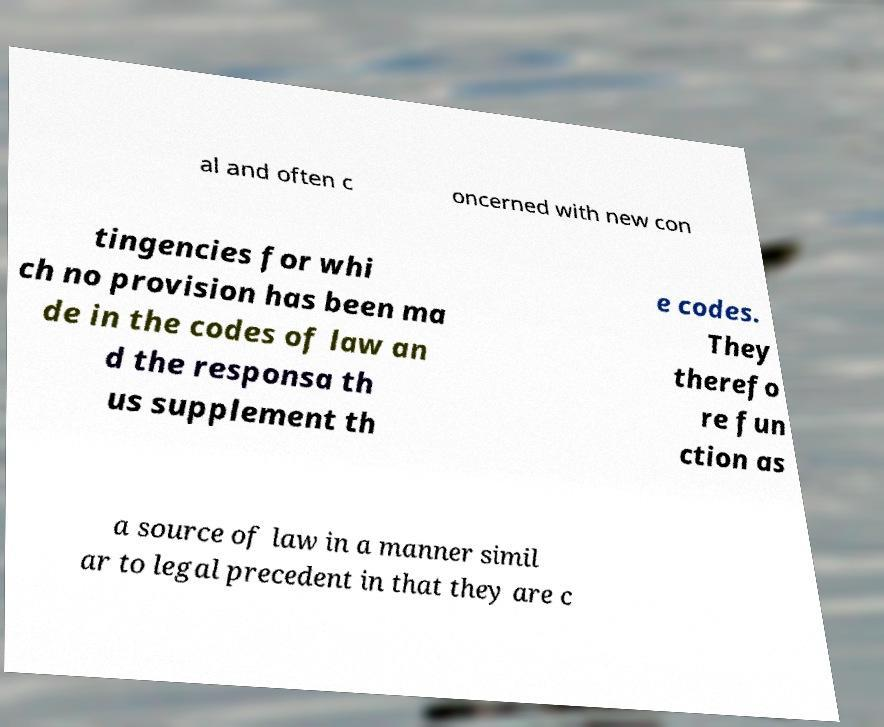For documentation purposes, I need the text within this image transcribed. Could you provide that? al and often c oncerned with new con tingencies for whi ch no provision has been ma de in the codes of law an d the responsa th us supplement th e codes. They therefo re fun ction as a source of law in a manner simil ar to legal precedent in that they are c 